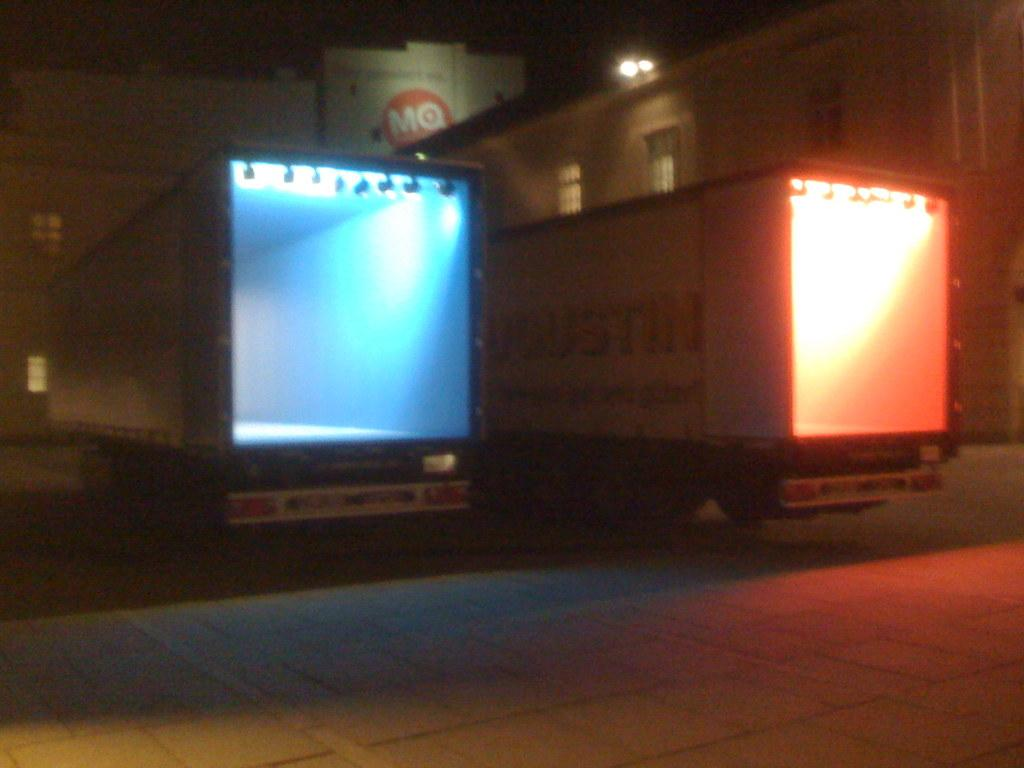<image>
Present a compact description of the photo's key features. Blue and orange truck under a red sign that says MQ on it. 